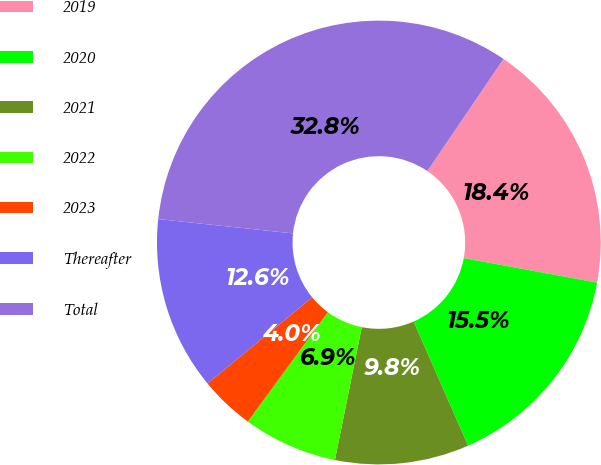<chart> <loc_0><loc_0><loc_500><loc_500><pie_chart><fcel>2019<fcel>2020<fcel>2021<fcel>2022<fcel>2023<fcel>Thereafter<fcel>Total<nl><fcel>18.4%<fcel>15.52%<fcel>9.76%<fcel>6.88%<fcel>3.99%<fcel>12.64%<fcel>32.81%<nl></chart> 